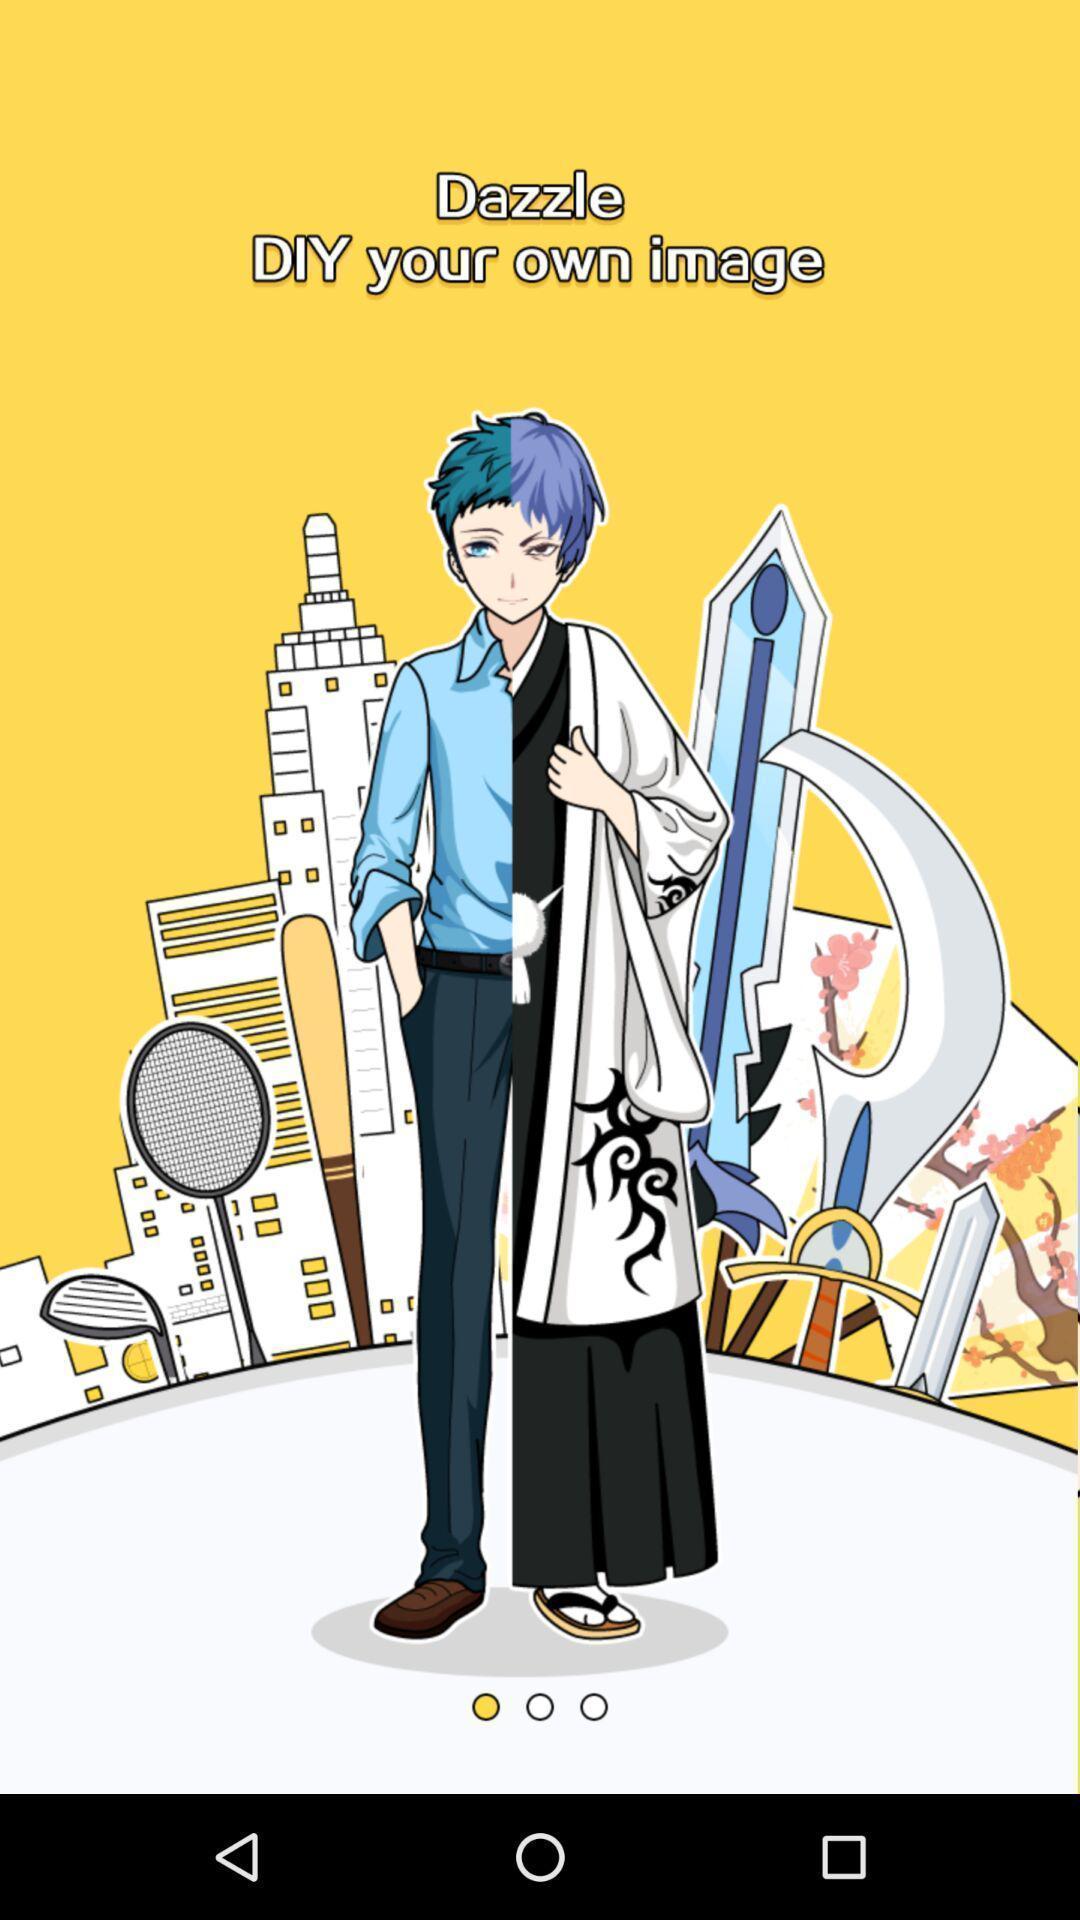Tell me what you see in this picture. Welcome page. 